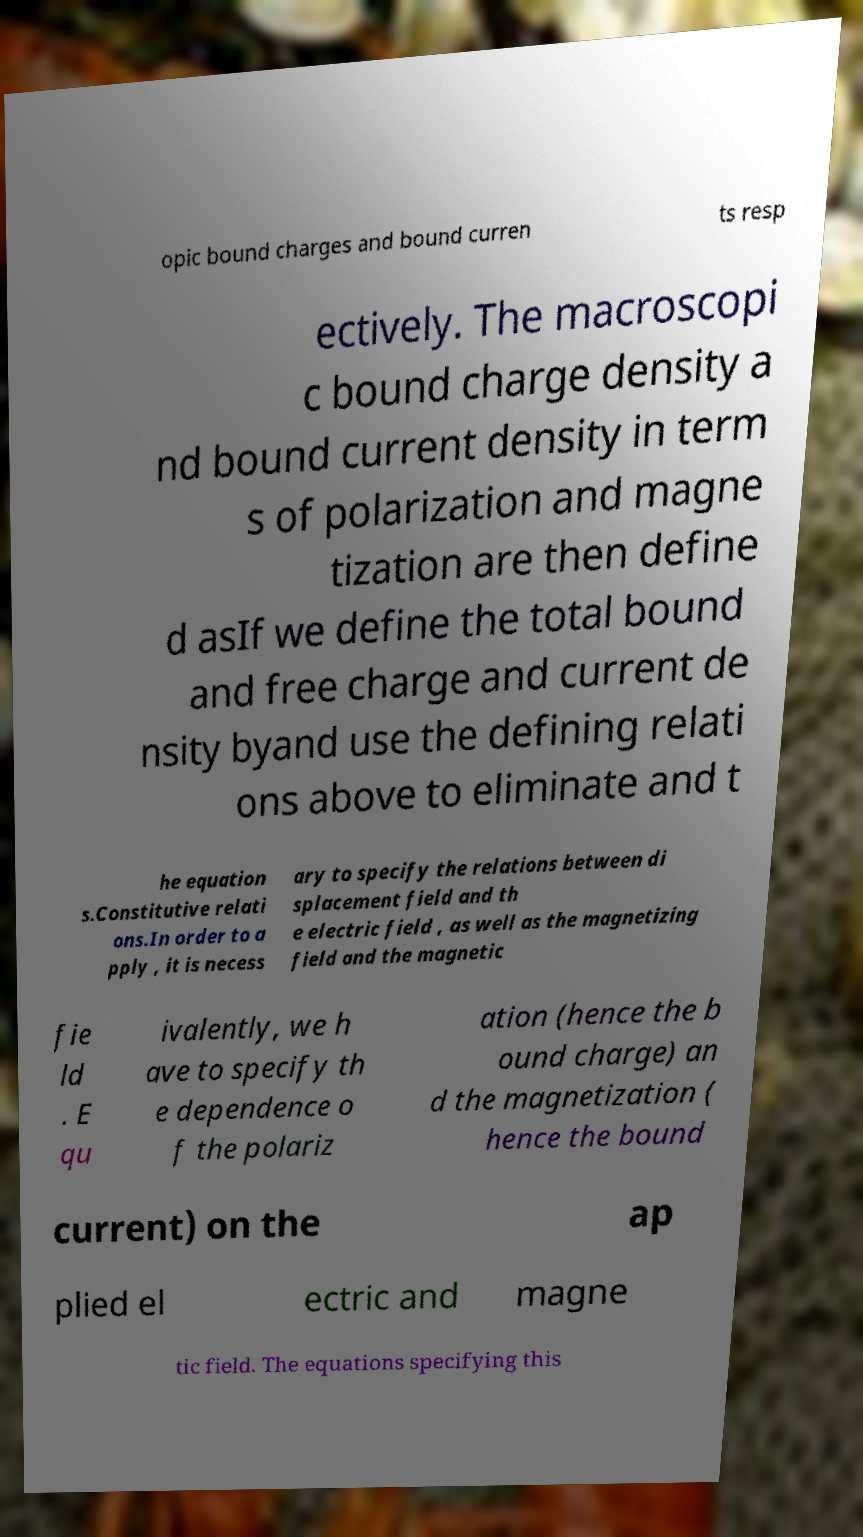Can you accurately transcribe the text from the provided image for me? opic bound charges and bound curren ts resp ectively. The macroscopi c bound charge density a nd bound current density in term s of polarization and magne tization are then define d asIf we define the total bound and free charge and current de nsity byand use the defining relati ons above to eliminate and t he equation s.Constitutive relati ons.In order to a pply , it is necess ary to specify the relations between di splacement field and th e electric field , as well as the magnetizing field and the magnetic fie ld . E qu ivalently, we h ave to specify th e dependence o f the polariz ation (hence the b ound charge) an d the magnetization ( hence the bound current) on the ap plied el ectric and magne tic field. The equations specifying this 